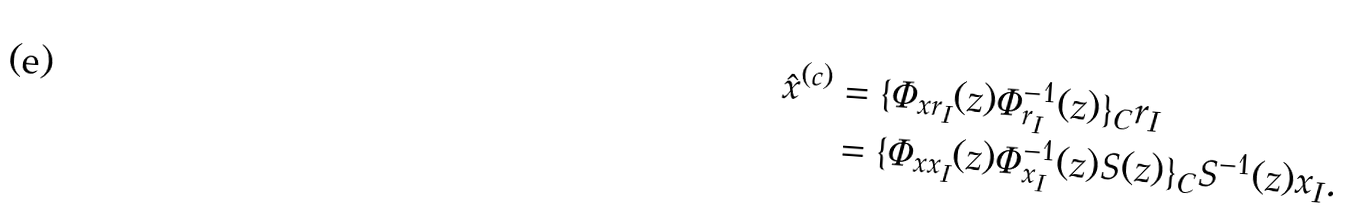Convert formula to latex. <formula><loc_0><loc_0><loc_500><loc_500>\hat { x } ^ { ( c ) } & = \{ \Phi _ { x r _ { I } } ( z ) \Phi ^ { - 1 } _ { r _ { I } } ( z ) \} _ { C } r _ { I } \\ & = \{ \Phi _ { x x _ { I } } ( z ) \Phi ^ { - 1 } _ { x _ { I } } ( z ) S ( z ) \} _ { C } S ^ { - 1 } ( z ) x _ { I } .</formula> 